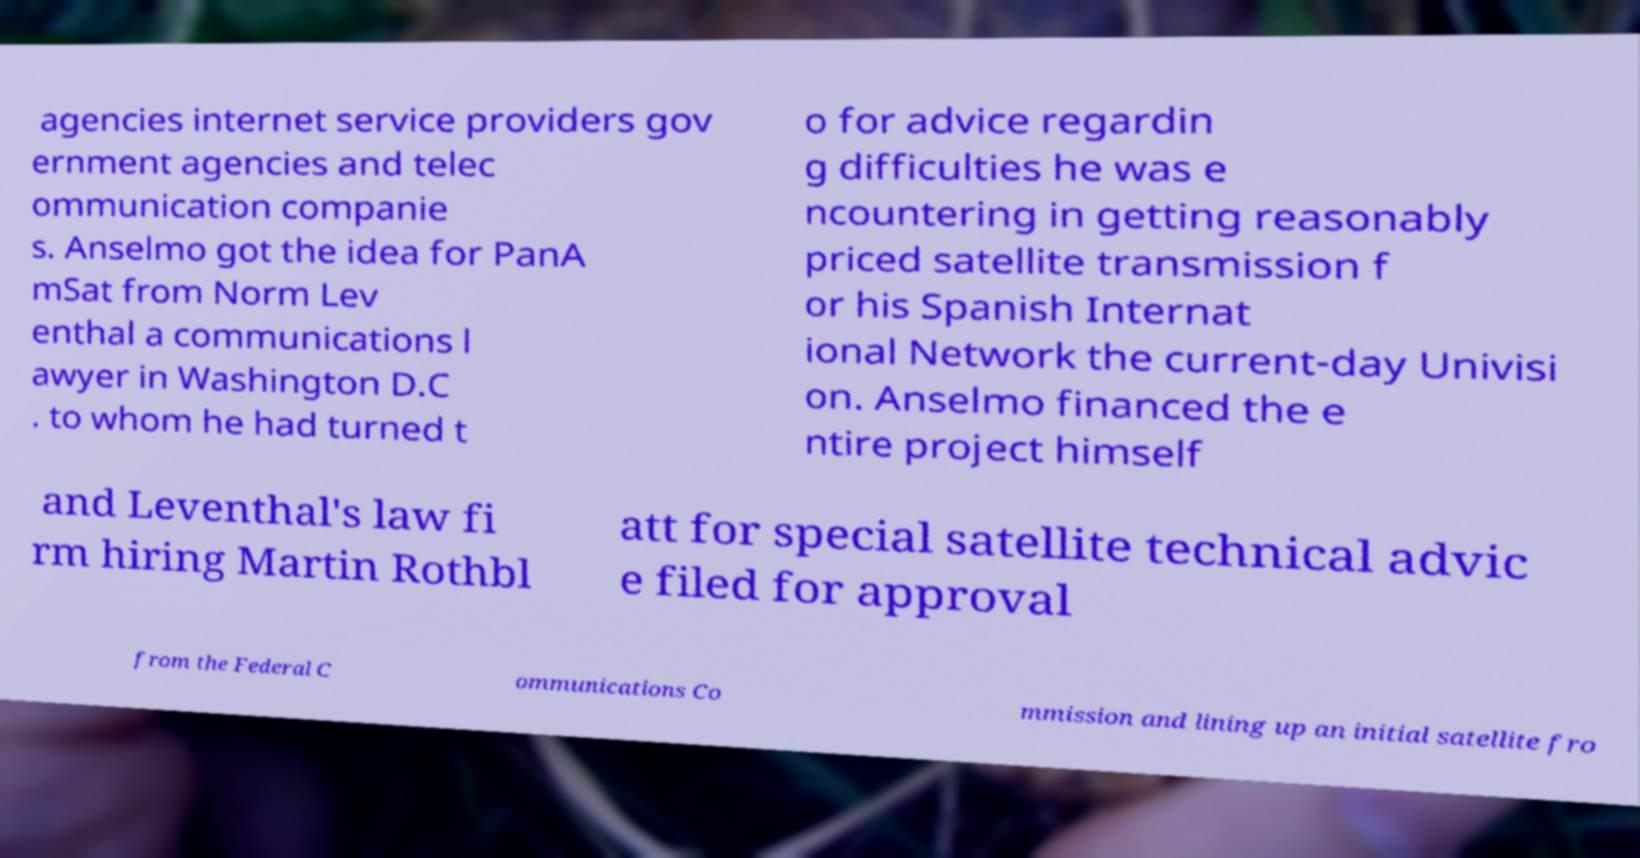For documentation purposes, I need the text within this image transcribed. Could you provide that? agencies internet service providers gov ernment agencies and telec ommunication companie s. Anselmo got the idea for PanA mSat from Norm Lev enthal a communications l awyer in Washington D.C . to whom he had turned t o for advice regardin g difficulties he was e ncountering in getting reasonably priced satellite transmission f or his Spanish Internat ional Network the current-day Univisi on. Anselmo financed the e ntire project himself and Leventhal's law fi rm hiring Martin Rothbl att for special satellite technical advic e filed for approval from the Federal C ommunications Co mmission and lining up an initial satellite fro 